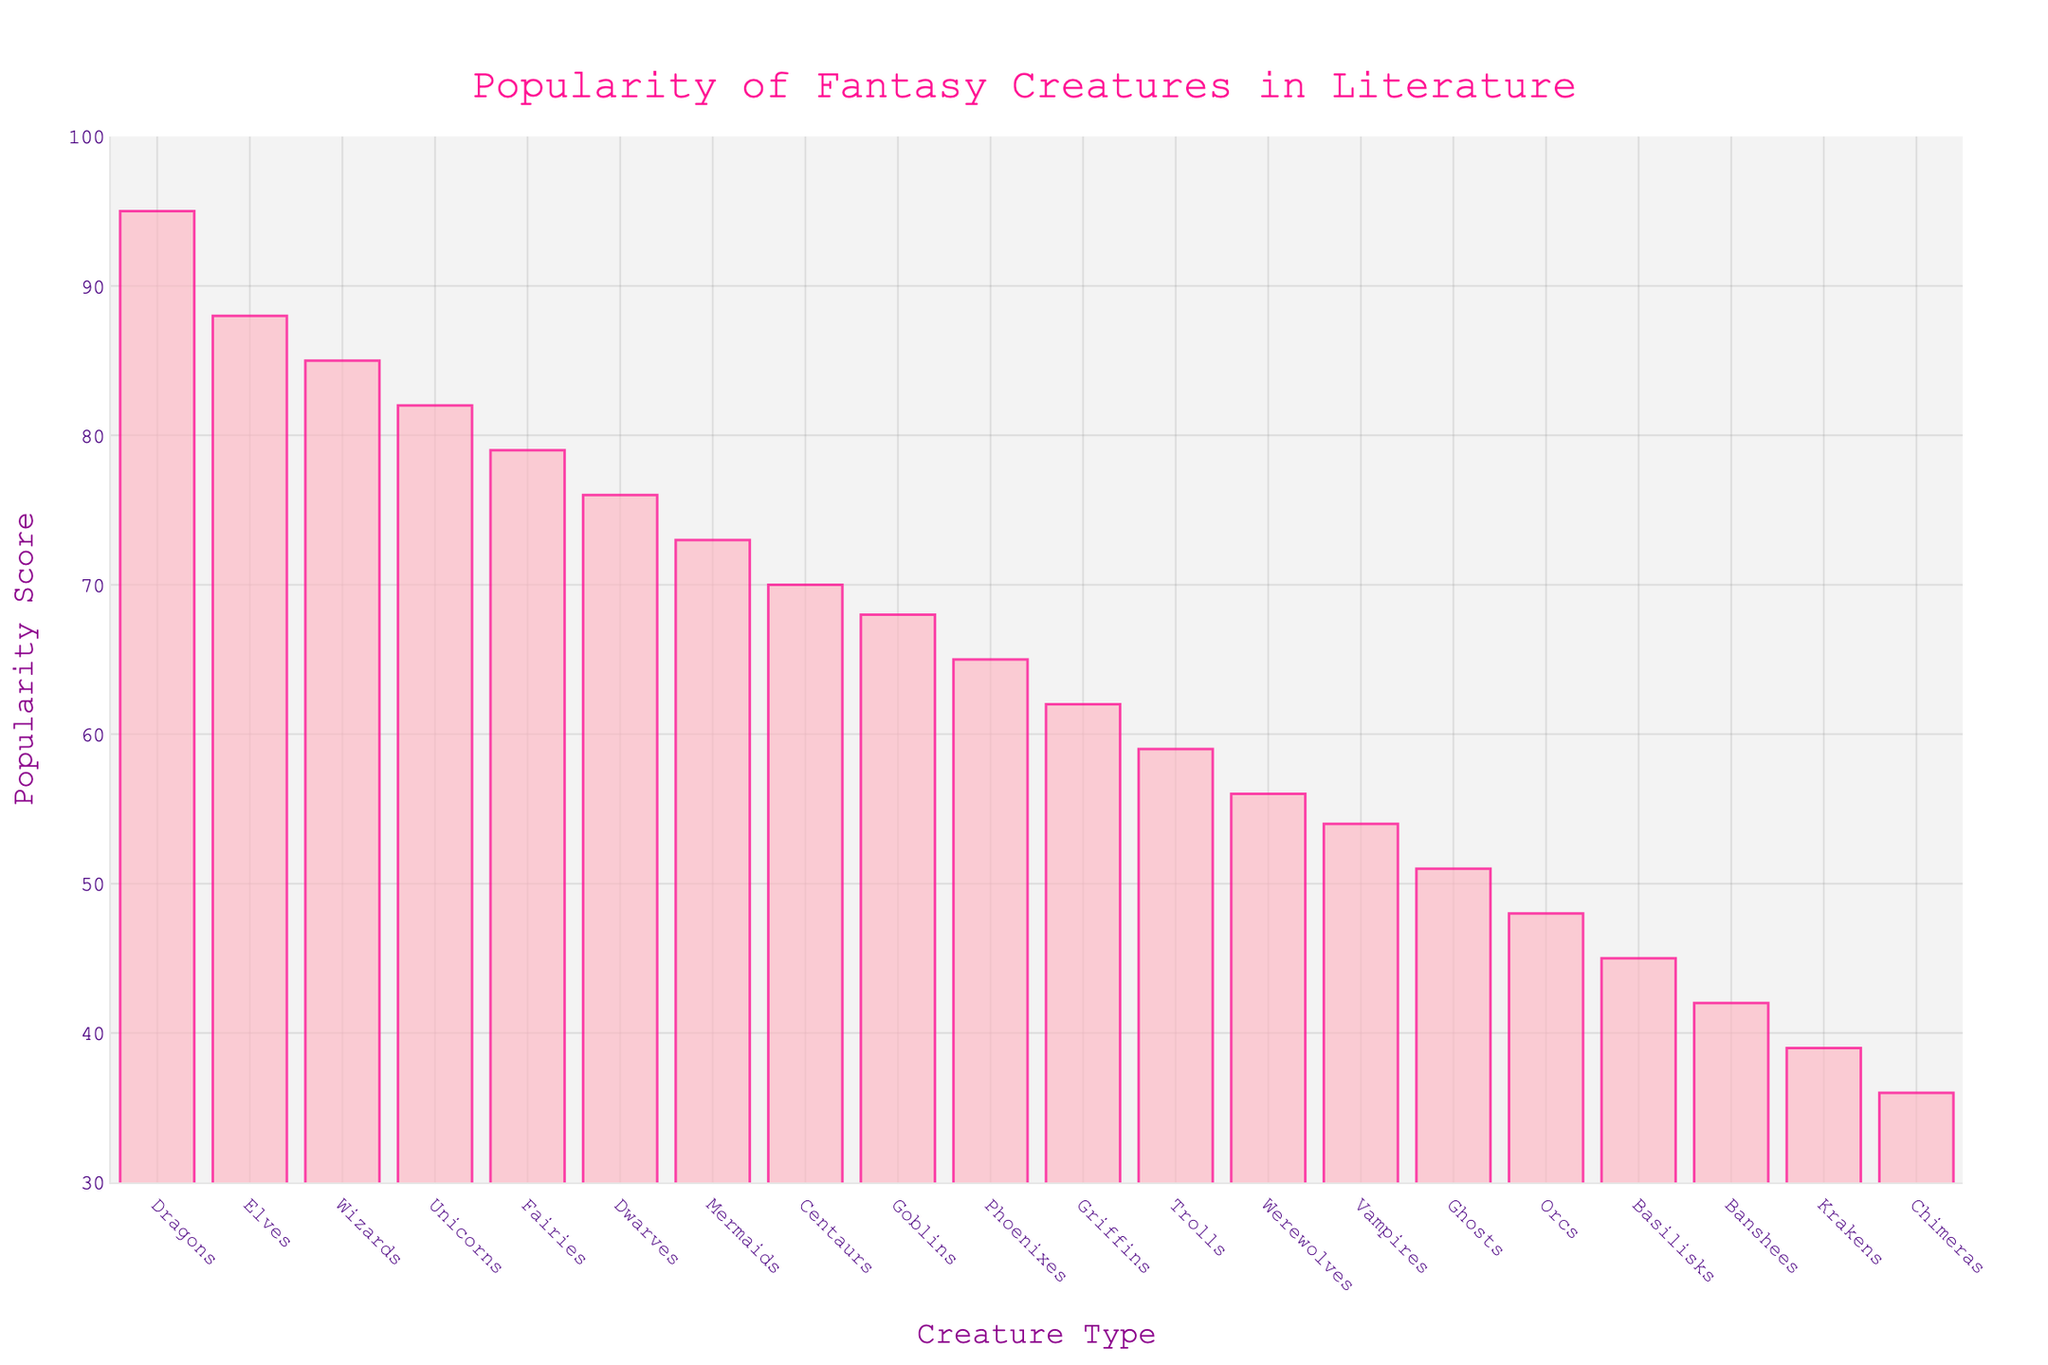Which fantasy creature has the highest popularity score? The highest bar represents the fantasy creature with the highest popularity score. The Dragons bar is the highest at 95.
Answer: Dragons Which creature has a higher popularity score, Elves or Griffins? Compare the height of the bars for Elves and Griffins. Elves have a score of 88 and Griffins have a score of 62. 88 > 62 indicates Elves have a higher score.
Answer: Elves What is the difference in popularity between Wizards and Dwarves? Find the bars for Wizards and Dwarves. Wizards have a score of 85 and Dwarves have a score of 76. Subtract 76 from 85: 85 - 76 = 9.
Answer: 9 What's the average popularity score of the top three creatures? Identify the top three creatures: Dragons (95), Elves (88), and Wizards (85). Calculate the average: (95 + 88 + 85) / 3 = 268 / 3 ≈ 89.3
Answer: 89.3 Are Trolls or Unicorns more popular? Compare the height of the bars for Trolls and Unicorns. Trolls have a score of 59 and Unicorns have a score of 82. 59 < 82, so Unicorns are more popular.
Answer: Unicorns What is the visual appearance of the bar representing Phoenixes? Look at the bar labeled Phoenixes. It is light pink with a deep pink border, and has a popularity score of 65.
Answer: Light pink bar with deep pink border, score of 65 What is the sum of the popularity scores for Goblins and Basilisks? Find the bars for Goblins and Basilisks. Goblins have a score of 68 and Basilisks have a score of 45. Add them: 68 + 45 = 113.
Answer: 113 Which creatures have a popularity score less than 50? Identify bars with scores below 50. These are Vampires (54), Ghosts (51), Orcs (48), Basilisks (45), Banshees (42), Krakens (39), and Chimeras (36).
Answer: Orcs, Basilisks, Banshees, Krakens, Chimeras 